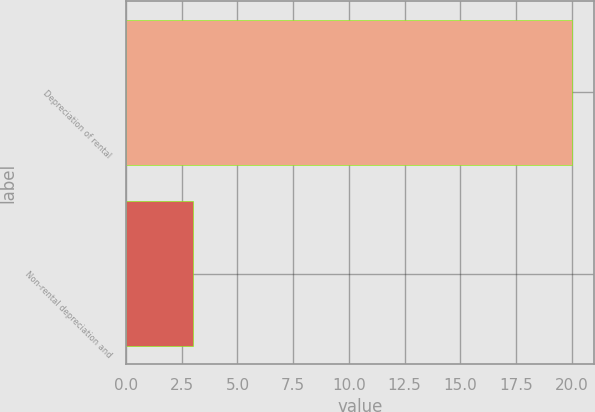Convert chart. <chart><loc_0><loc_0><loc_500><loc_500><bar_chart><fcel>Depreciation of rental<fcel>Non-rental depreciation and<nl><fcel>20<fcel>3<nl></chart> 